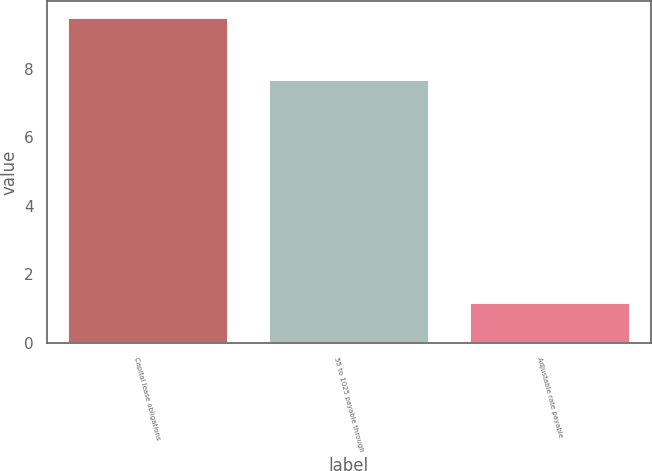Convert chart. <chart><loc_0><loc_0><loc_500><loc_500><bar_chart><fcel>Capital lease obligations<fcel>55 to 1025 payable through<fcel>Adjustable rate payable<nl><fcel>9.5<fcel>7.7<fcel>1.2<nl></chart> 